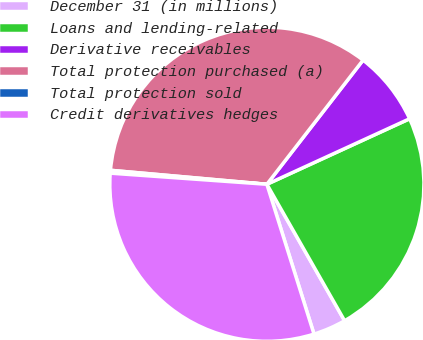<chart> <loc_0><loc_0><loc_500><loc_500><pie_chart><fcel>December 31 (in millions)<fcel>Loans and lending-related<fcel>Derivative receivables<fcel>Total protection purchased (a)<fcel>Total protection sold<fcel>Credit derivatives hedges<nl><fcel>3.39%<fcel>23.61%<fcel>7.66%<fcel>34.07%<fcel>0.29%<fcel>30.98%<nl></chart> 